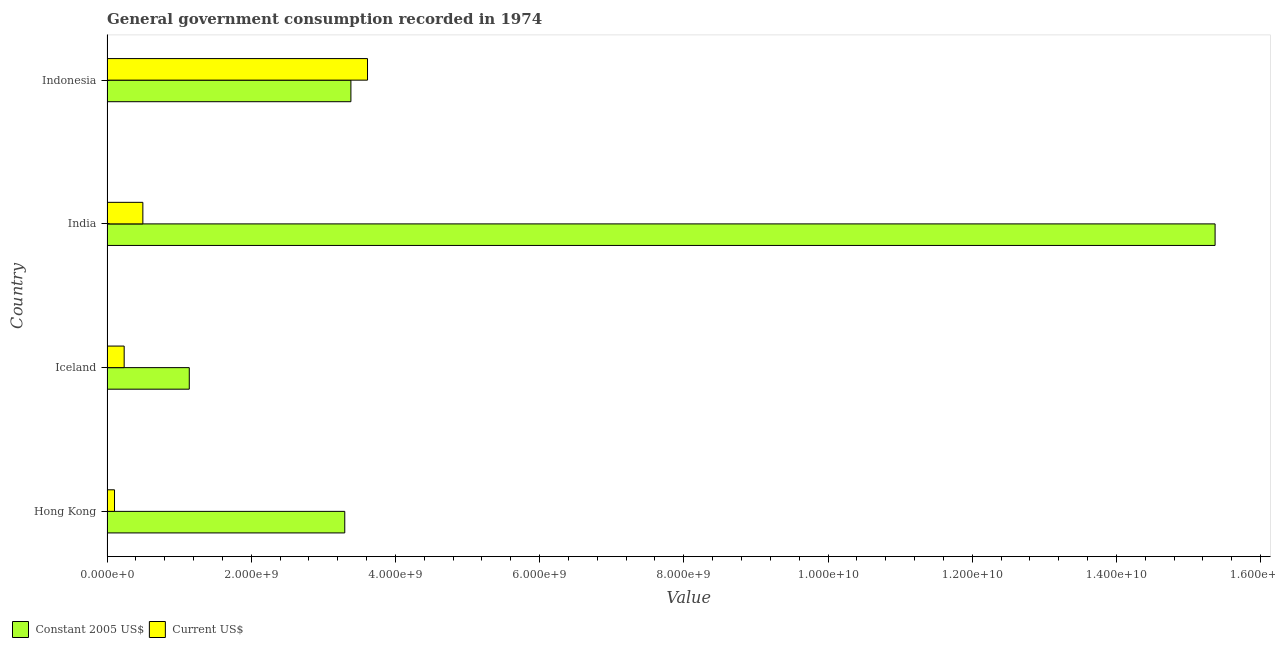Are the number of bars per tick equal to the number of legend labels?
Make the answer very short. Yes. Are the number of bars on each tick of the Y-axis equal?
Make the answer very short. Yes. How many bars are there on the 3rd tick from the bottom?
Offer a terse response. 2. What is the value consumed in constant 2005 us$ in Hong Kong?
Give a very brief answer. 3.30e+09. Across all countries, what is the maximum value consumed in current us$?
Your answer should be compact. 3.61e+09. Across all countries, what is the minimum value consumed in current us$?
Offer a terse response. 1.04e+08. In which country was the value consumed in constant 2005 us$ minimum?
Your response must be concise. Iceland. What is the total value consumed in constant 2005 us$ in the graph?
Your answer should be compact. 2.32e+1. What is the difference between the value consumed in current us$ in Hong Kong and that in Indonesia?
Give a very brief answer. -3.51e+09. What is the difference between the value consumed in constant 2005 us$ in Iceland and the value consumed in current us$ in India?
Ensure brevity in your answer.  6.44e+08. What is the average value consumed in constant 2005 us$ per country?
Ensure brevity in your answer.  5.80e+09. What is the difference between the value consumed in current us$ and value consumed in constant 2005 us$ in Hong Kong?
Provide a short and direct response. -3.19e+09. What is the ratio of the value consumed in current us$ in Hong Kong to that in India?
Your answer should be very brief. 0.21. Is the value consumed in current us$ in Iceland less than that in Indonesia?
Provide a short and direct response. Yes. What is the difference between the highest and the second highest value consumed in constant 2005 us$?
Your answer should be very brief. 1.20e+1. What is the difference between the highest and the lowest value consumed in constant 2005 us$?
Keep it short and to the point. 1.42e+1. In how many countries, is the value consumed in current us$ greater than the average value consumed in current us$ taken over all countries?
Provide a succinct answer. 1. Is the sum of the value consumed in constant 2005 us$ in Hong Kong and Indonesia greater than the maximum value consumed in current us$ across all countries?
Your response must be concise. Yes. What does the 2nd bar from the top in Iceland represents?
Your answer should be compact. Constant 2005 US$. What does the 2nd bar from the bottom in Hong Kong represents?
Your answer should be compact. Current US$. Does the graph contain any zero values?
Give a very brief answer. No. Does the graph contain grids?
Offer a very short reply. No. Where does the legend appear in the graph?
Give a very brief answer. Bottom left. What is the title of the graph?
Offer a terse response. General government consumption recorded in 1974. What is the label or title of the X-axis?
Your answer should be compact. Value. What is the label or title of the Y-axis?
Offer a terse response. Country. What is the Value in Constant 2005 US$ in Hong Kong?
Your response must be concise. 3.30e+09. What is the Value in Current US$ in Hong Kong?
Provide a succinct answer. 1.04e+08. What is the Value in Constant 2005 US$ in Iceland?
Offer a terse response. 1.14e+09. What is the Value of Current US$ in Iceland?
Your answer should be very brief. 2.38e+08. What is the Value in Constant 2005 US$ in India?
Provide a short and direct response. 1.54e+1. What is the Value in Current US$ in India?
Give a very brief answer. 4.97e+08. What is the Value in Constant 2005 US$ in Indonesia?
Make the answer very short. 3.38e+09. What is the Value of Current US$ in Indonesia?
Make the answer very short. 3.61e+09. Across all countries, what is the maximum Value in Constant 2005 US$?
Offer a terse response. 1.54e+1. Across all countries, what is the maximum Value of Current US$?
Ensure brevity in your answer.  3.61e+09. Across all countries, what is the minimum Value in Constant 2005 US$?
Keep it short and to the point. 1.14e+09. Across all countries, what is the minimum Value in Current US$?
Your answer should be very brief. 1.04e+08. What is the total Value in Constant 2005 US$ in the graph?
Provide a succinct answer. 2.32e+1. What is the total Value in Current US$ in the graph?
Provide a succinct answer. 4.45e+09. What is the difference between the Value in Constant 2005 US$ in Hong Kong and that in Iceland?
Your response must be concise. 2.16e+09. What is the difference between the Value in Current US$ in Hong Kong and that in Iceland?
Provide a succinct answer. -1.34e+08. What is the difference between the Value in Constant 2005 US$ in Hong Kong and that in India?
Make the answer very short. -1.21e+1. What is the difference between the Value of Current US$ in Hong Kong and that in India?
Give a very brief answer. -3.93e+08. What is the difference between the Value of Constant 2005 US$ in Hong Kong and that in Indonesia?
Give a very brief answer. -8.52e+07. What is the difference between the Value of Current US$ in Hong Kong and that in Indonesia?
Offer a very short reply. -3.51e+09. What is the difference between the Value in Constant 2005 US$ in Iceland and that in India?
Make the answer very short. -1.42e+1. What is the difference between the Value of Current US$ in Iceland and that in India?
Your response must be concise. -2.59e+08. What is the difference between the Value of Constant 2005 US$ in Iceland and that in Indonesia?
Your response must be concise. -2.24e+09. What is the difference between the Value of Current US$ in Iceland and that in Indonesia?
Offer a very short reply. -3.37e+09. What is the difference between the Value in Constant 2005 US$ in India and that in Indonesia?
Provide a succinct answer. 1.20e+1. What is the difference between the Value of Current US$ in India and that in Indonesia?
Offer a very short reply. -3.12e+09. What is the difference between the Value in Constant 2005 US$ in Hong Kong and the Value in Current US$ in Iceland?
Your answer should be compact. 3.06e+09. What is the difference between the Value in Constant 2005 US$ in Hong Kong and the Value in Current US$ in India?
Your response must be concise. 2.80e+09. What is the difference between the Value in Constant 2005 US$ in Hong Kong and the Value in Current US$ in Indonesia?
Make the answer very short. -3.16e+08. What is the difference between the Value of Constant 2005 US$ in Iceland and the Value of Current US$ in India?
Provide a short and direct response. 6.44e+08. What is the difference between the Value in Constant 2005 US$ in Iceland and the Value in Current US$ in Indonesia?
Give a very brief answer. -2.47e+09. What is the difference between the Value in Constant 2005 US$ in India and the Value in Current US$ in Indonesia?
Your response must be concise. 1.18e+1. What is the average Value of Constant 2005 US$ per country?
Provide a short and direct response. 5.80e+09. What is the average Value of Current US$ per country?
Your response must be concise. 1.11e+09. What is the difference between the Value in Constant 2005 US$ and Value in Current US$ in Hong Kong?
Keep it short and to the point. 3.19e+09. What is the difference between the Value in Constant 2005 US$ and Value in Current US$ in Iceland?
Offer a terse response. 9.03e+08. What is the difference between the Value of Constant 2005 US$ and Value of Current US$ in India?
Keep it short and to the point. 1.49e+1. What is the difference between the Value of Constant 2005 US$ and Value of Current US$ in Indonesia?
Offer a very short reply. -2.30e+08. What is the ratio of the Value of Constant 2005 US$ in Hong Kong to that in Iceland?
Ensure brevity in your answer.  2.89. What is the ratio of the Value of Current US$ in Hong Kong to that in Iceland?
Make the answer very short. 0.44. What is the ratio of the Value of Constant 2005 US$ in Hong Kong to that in India?
Ensure brevity in your answer.  0.21. What is the ratio of the Value in Current US$ in Hong Kong to that in India?
Give a very brief answer. 0.21. What is the ratio of the Value of Constant 2005 US$ in Hong Kong to that in Indonesia?
Keep it short and to the point. 0.97. What is the ratio of the Value in Current US$ in Hong Kong to that in Indonesia?
Make the answer very short. 0.03. What is the ratio of the Value of Constant 2005 US$ in Iceland to that in India?
Make the answer very short. 0.07. What is the ratio of the Value in Current US$ in Iceland to that in India?
Your response must be concise. 0.48. What is the ratio of the Value of Constant 2005 US$ in Iceland to that in Indonesia?
Make the answer very short. 0.34. What is the ratio of the Value in Current US$ in Iceland to that in Indonesia?
Offer a very short reply. 0.07. What is the ratio of the Value of Constant 2005 US$ in India to that in Indonesia?
Provide a succinct answer. 4.54. What is the ratio of the Value in Current US$ in India to that in Indonesia?
Offer a very short reply. 0.14. What is the difference between the highest and the second highest Value in Constant 2005 US$?
Your response must be concise. 1.20e+1. What is the difference between the highest and the second highest Value in Current US$?
Your answer should be very brief. 3.12e+09. What is the difference between the highest and the lowest Value of Constant 2005 US$?
Your response must be concise. 1.42e+1. What is the difference between the highest and the lowest Value in Current US$?
Offer a terse response. 3.51e+09. 